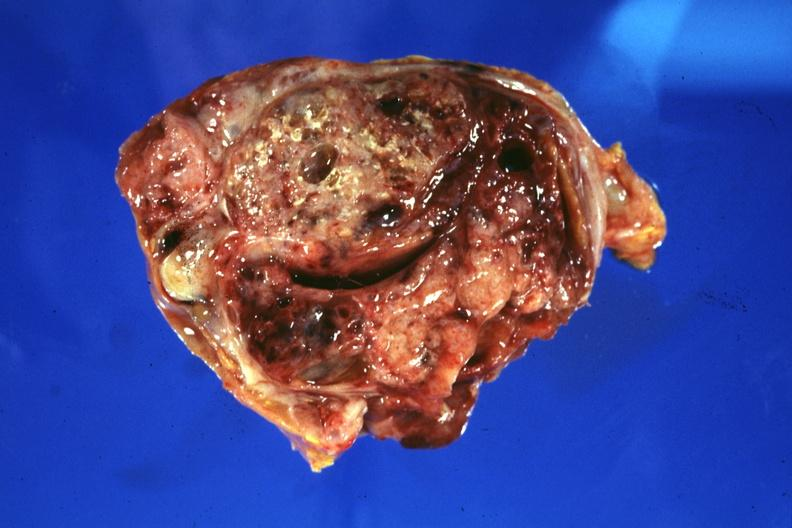what does this image show?
Answer the question using a single word or phrase. Cross section of tumor 